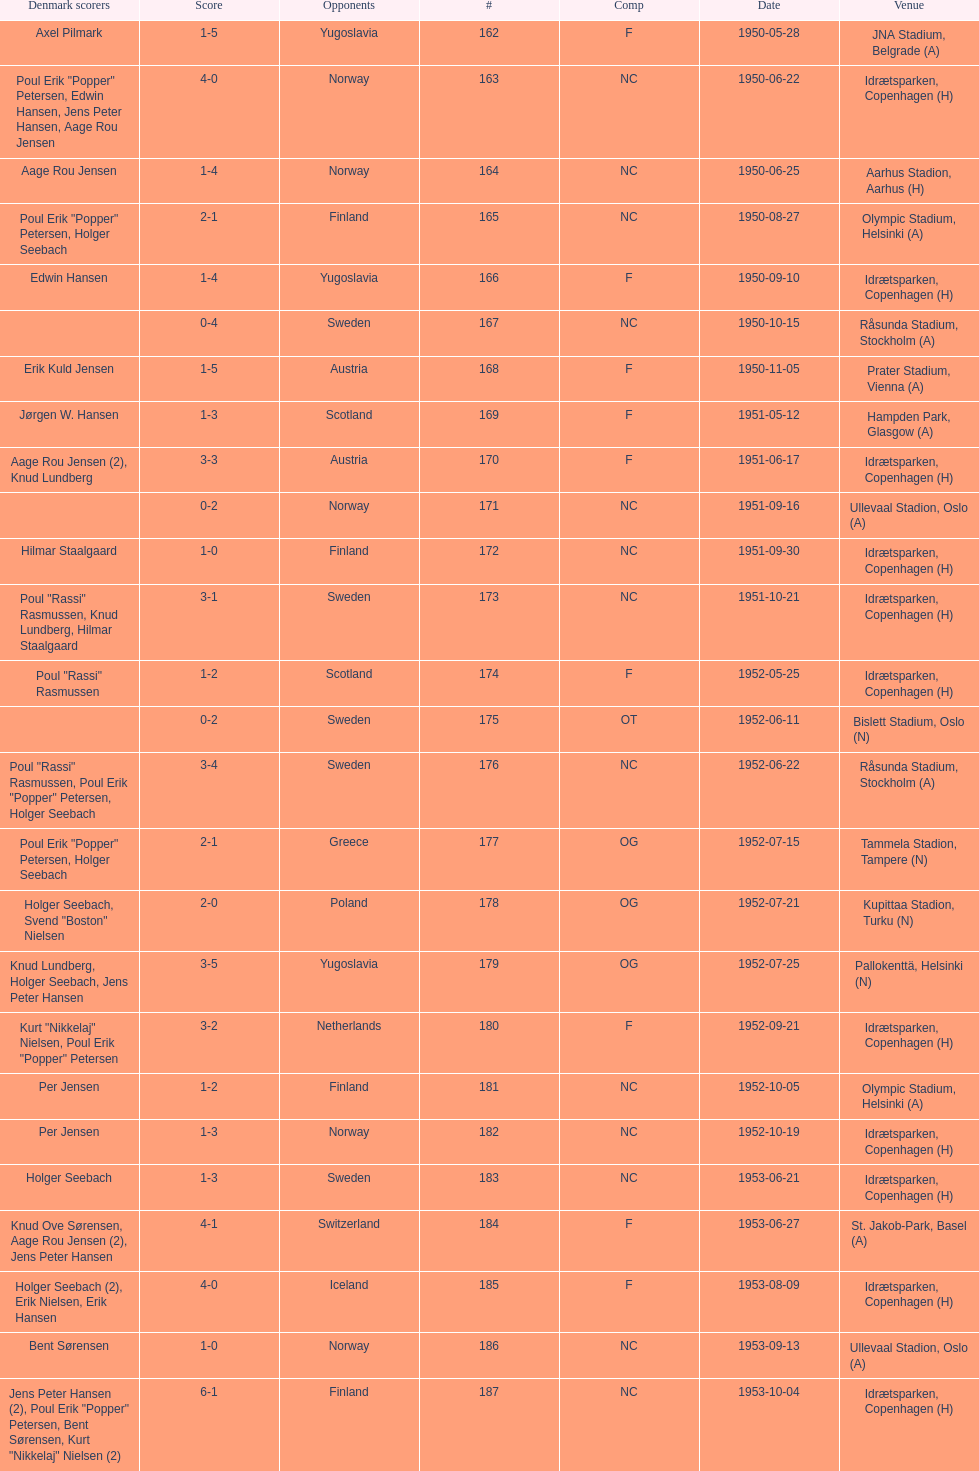What is the title of the location mentioned prior to olympic stadium on 1950-08-27? Aarhus Stadion, Aarhus. 